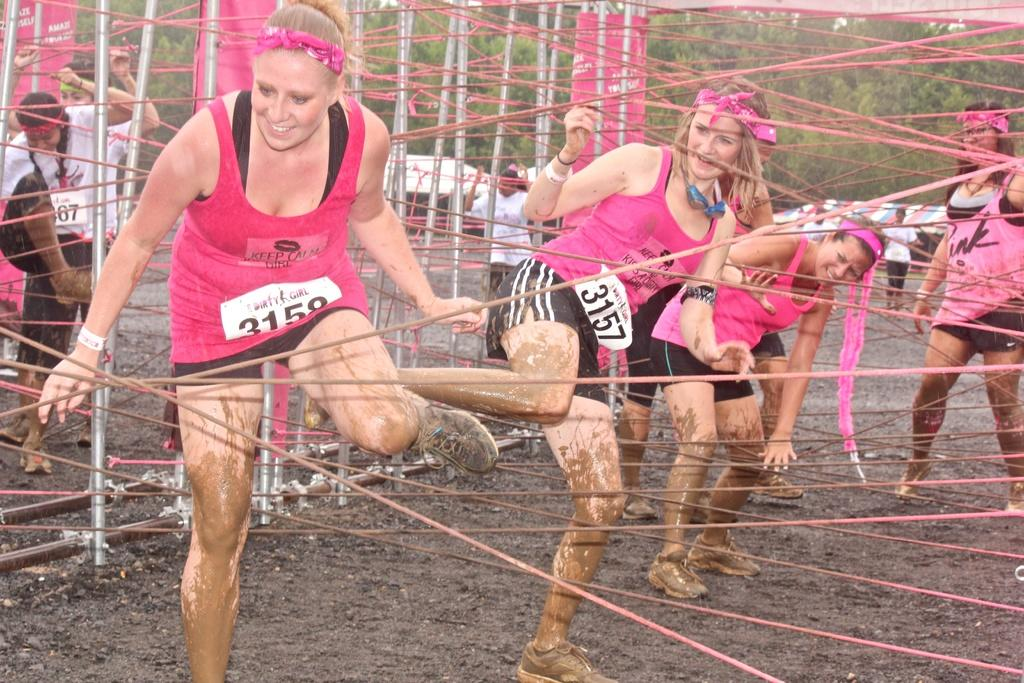What is the main subject of the image? The main subject of the image is girls. Where are the girls located in the image? The girls are in the center of the image. What are the girls doing in the image? The girls are playing. What type of stocking can be seen on the girls' legs in the image? There is no mention of stockings or any specific clothing items on the girls' legs in the image. What kind of butter is being used by the girls in the image? There is no butter or any food items present in the image. 